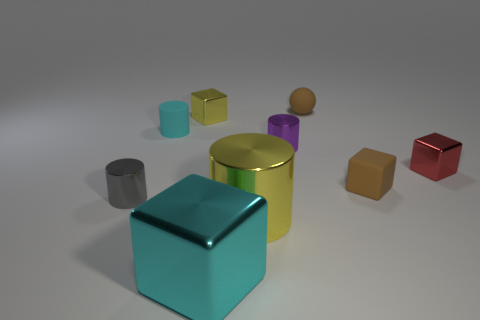There is a block that is the same color as the big metal cylinder; what size is it?
Provide a short and direct response. Small. How many small objects are metallic things or yellow objects?
Provide a short and direct response. 4. What material is the cube that is the same color as the small matte cylinder?
Your answer should be very brief. Metal. Are there any small purple objects made of the same material as the small purple cylinder?
Give a very brief answer. No. Does the yellow metal thing that is right of the cyan shiny thing have the same size as the big block?
Ensure brevity in your answer.  Yes. There is a yellow shiny thing on the right side of the cyan thing that is in front of the cyan cylinder; is there a small brown rubber sphere to the left of it?
Provide a succinct answer. No. How many shiny things are tiny things or balls?
Offer a terse response. 4. How many other objects are there of the same shape as the tiny red metallic thing?
Provide a short and direct response. 3. Is the number of big yellow rubber cubes greater than the number of purple objects?
Your answer should be compact. No. There is a cyan object that is behind the metallic cylinder that is left of the tiny metallic block behind the tiny red block; what size is it?
Your answer should be compact. Small. 